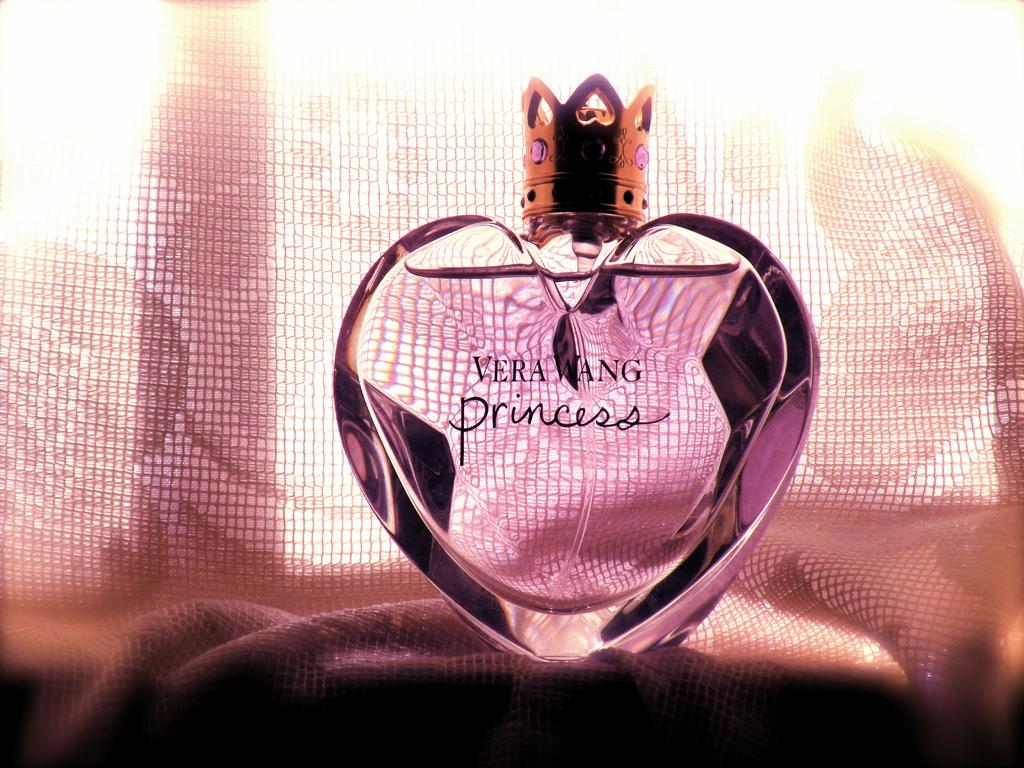<image>
Relay a brief, clear account of the picture shown. A pink heart shaped bottle of Vera Wang Princess perfume. 